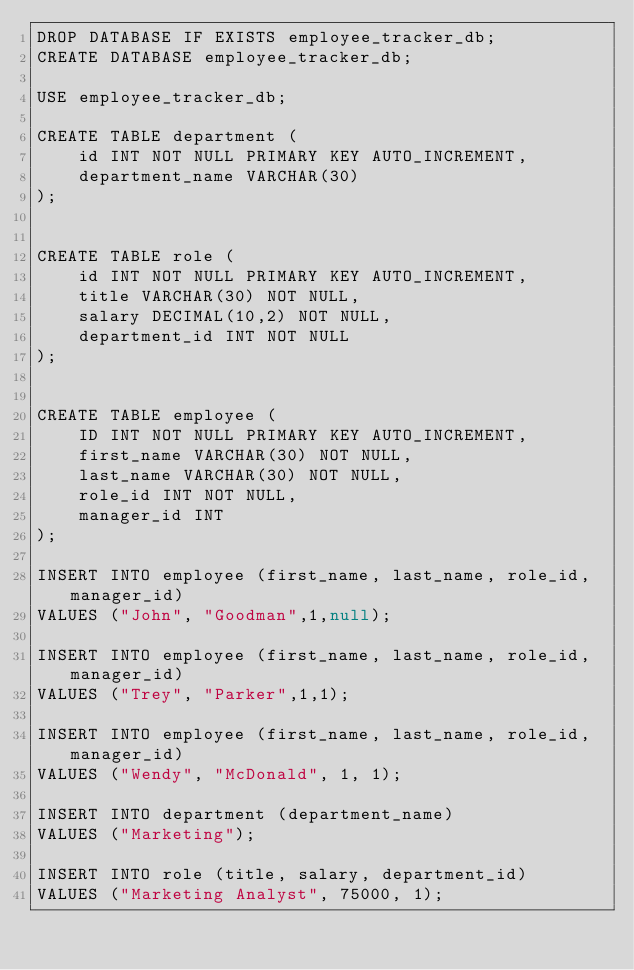Convert code to text. <code><loc_0><loc_0><loc_500><loc_500><_SQL_>DROP DATABASE IF EXISTS employee_tracker_db;
CREATE DATABASE employee_tracker_db;

USE employee_tracker_db;

CREATE TABLE department (
    id INT NOT NULL PRIMARY KEY AUTO_INCREMENT,
    department_name VARCHAR(30)    
);


CREATE TABLE role (
    id INT NOT NULL PRIMARY KEY AUTO_INCREMENT,
    title VARCHAR(30) NOT NULL,
    salary DECIMAL(10,2) NOT NULL,
    department_id INT NOT NULL    
);


CREATE TABLE employee (
    ID INT NOT NULL PRIMARY KEY AUTO_INCREMENT,
    first_name VARCHAR(30) NOT NULL,
    last_name VARCHAR(30) NOT NULL,
    role_id INT NOT NULL,
    manager_id INT      
);

INSERT INTO employee (first_name, last_name, role_id, manager_id)
VALUES ("John", "Goodman",1,null);

INSERT INTO employee (first_name, last_name, role_id, manager_id)
VALUES ("Trey", "Parker",1,1);

INSERT INTO employee (first_name, last_name, role_id, manager_id)
VALUES ("Wendy", "McDonald", 1, 1);

INSERT INTO department (department_name)
VALUES ("Marketing");

INSERT INTO role (title, salary, department_id)
VALUES ("Marketing Analyst", 75000, 1);</code> 